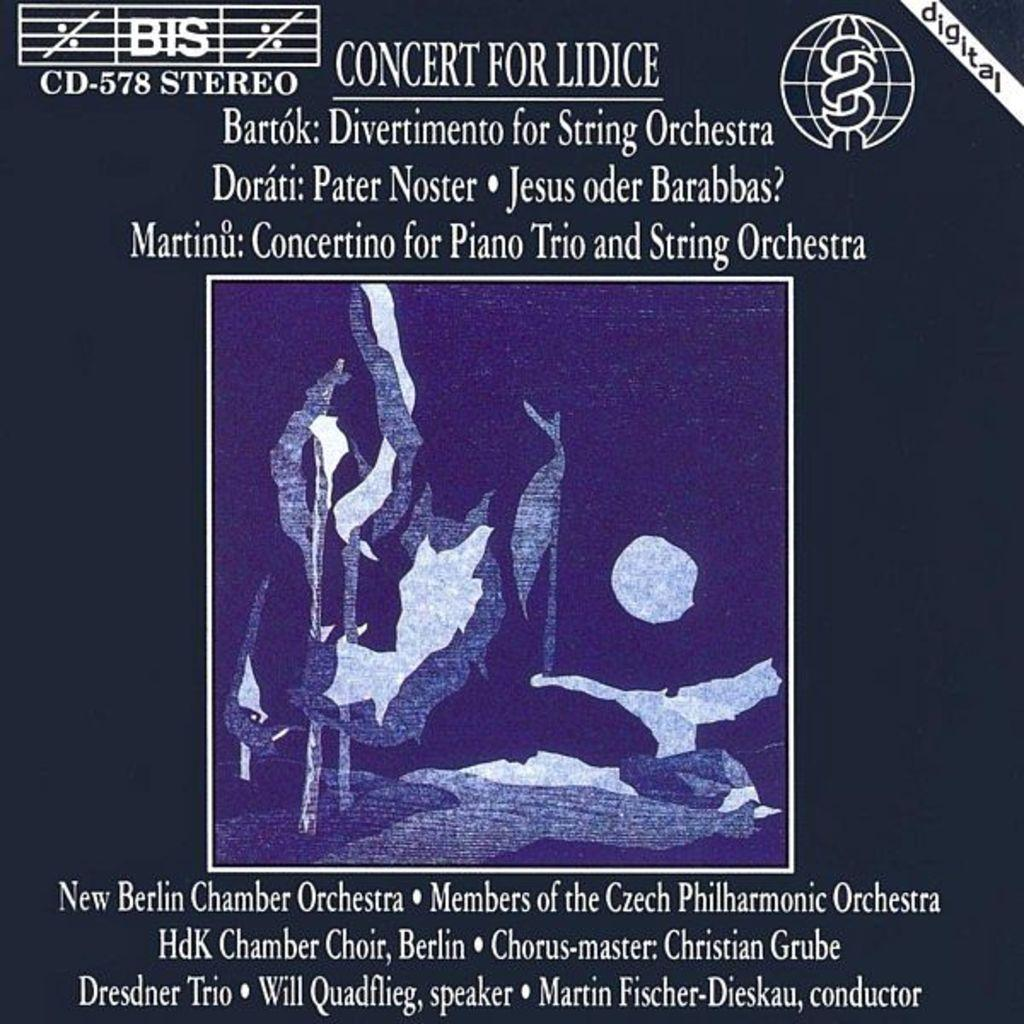<image>
Share a concise interpretation of the image provided. Album cover for Concert For Lidice with the numbers 578 on it. 